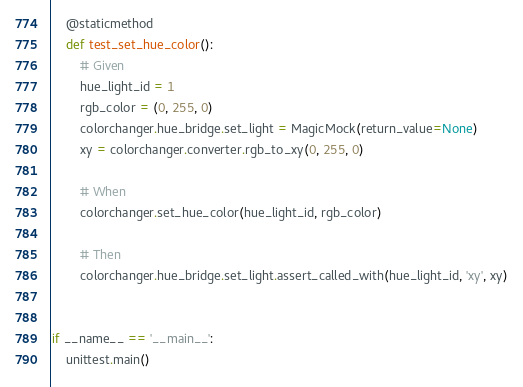<code> <loc_0><loc_0><loc_500><loc_500><_Python_>    @staticmethod
    def test_set_hue_color():
        # Given
        hue_light_id = 1
        rgb_color = (0, 255, 0)
        colorchanger.hue_bridge.set_light = MagicMock(return_value=None)
        xy = colorchanger.converter.rgb_to_xy(0, 255, 0)

        # When
        colorchanger.set_hue_color(hue_light_id, rgb_color)

        # Then
        colorchanger.hue_bridge.set_light.assert_called_with(hue_light_id, 'xy', xy)


if __name__ == '__main__':
    unittest.main()
</code> 